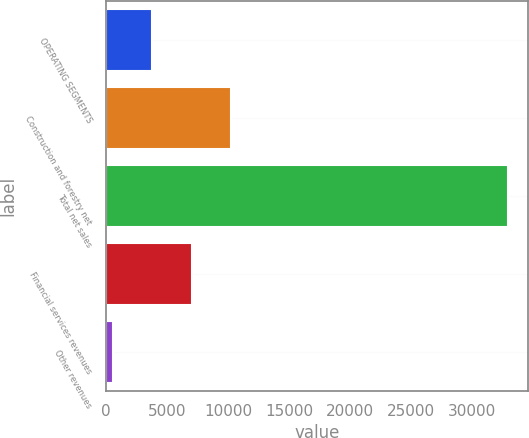Convert chart. <chart><loc_0><loc_0><loc_500><loc_500><bar_chart><fcel>OPERATING SEGMENTS<fcel>Construction and forestry net<fcel>Total net sales<fcel>Financial services revenues<fcel>Other revenues<nl><fcel>3772.2<fcel>10258.6<fcel>32961<fcel>7015.4<fcel>529<nl></chart> 